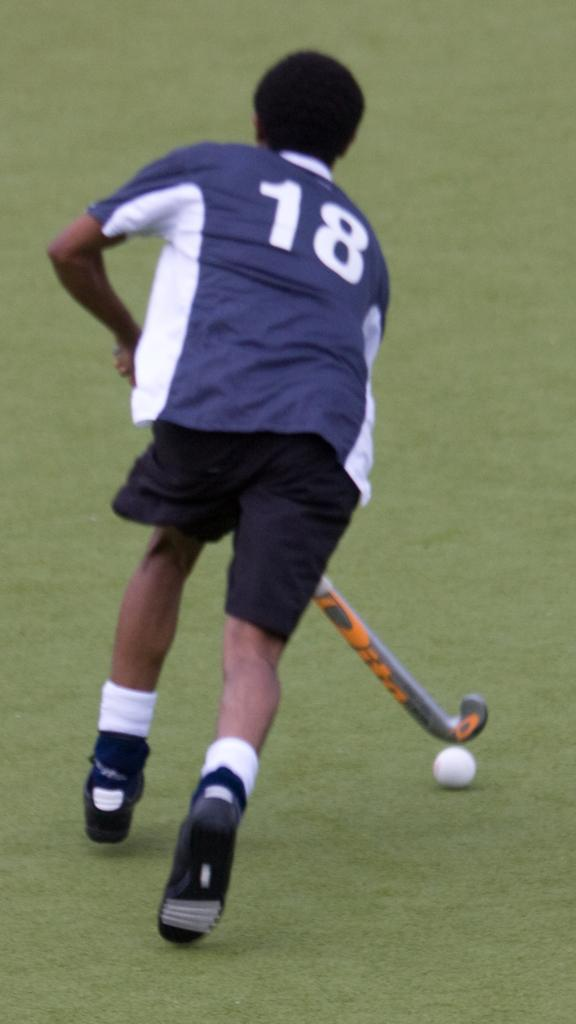What is the person in the image doing? The person is playing hockey. What object is being used in the game? There is a hockey ball in the image. Can you describe the time of day when the image was taken? The image appears to be taken during the day. What type of soup is being served in the image? There is no soup present in the image; it features a person playing hockey. Can you tell me who placed the order for the hockey equipment in the image? There is no information about ordering hockey equipment in the image; it simply shows a person playing hockey. 